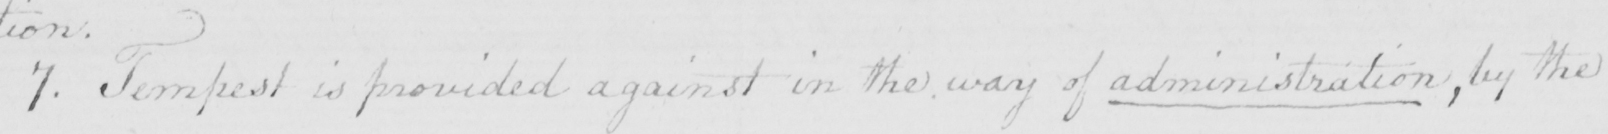What does this handwritten line say? 7 . Tempest is provided against in the way of administration , by the 